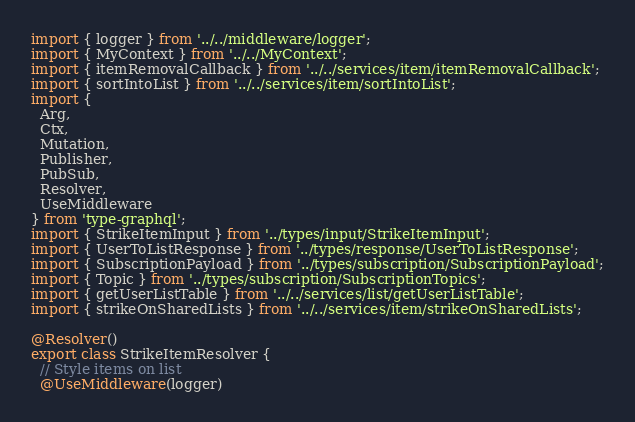<code> <loc_0><loc_0><loc_500><loc_500><_TypeScript_>import { logger } from '../../middleware/logger';
import { MyContext } from '../../MyContext';
import { itemRemovalCallback } from '../../services/item/itemRemovalCallback';
import { sortIntoList } from '../../services/item/sortIntoList';
import {
  Arg,
  Ctx,
  Mutation,
  Publisher,
  PubSub,
  Resolver,
  UseMiddleware
} from 'type-graphql';
import { StrikeItemInput } from '../types/input/StrikeItemInput';
import { UserToListResponse } from '../types/response/UserToListResponse';
import { SubscriptionPayload } from '../types/subscription/SubscriptionPayload';
import { Topic } from '../types/subscription/SubscriptionTopics';
import { getUserListTable } from '../../services/list/getUserListTable';
import { strikeOnSharedLists } from '../../services/item/strikeOnSharedLists';

@Resolver()
export class StrikeItemResolver {
  // Style items on list
  @UseMiddleware(logger)</code> 